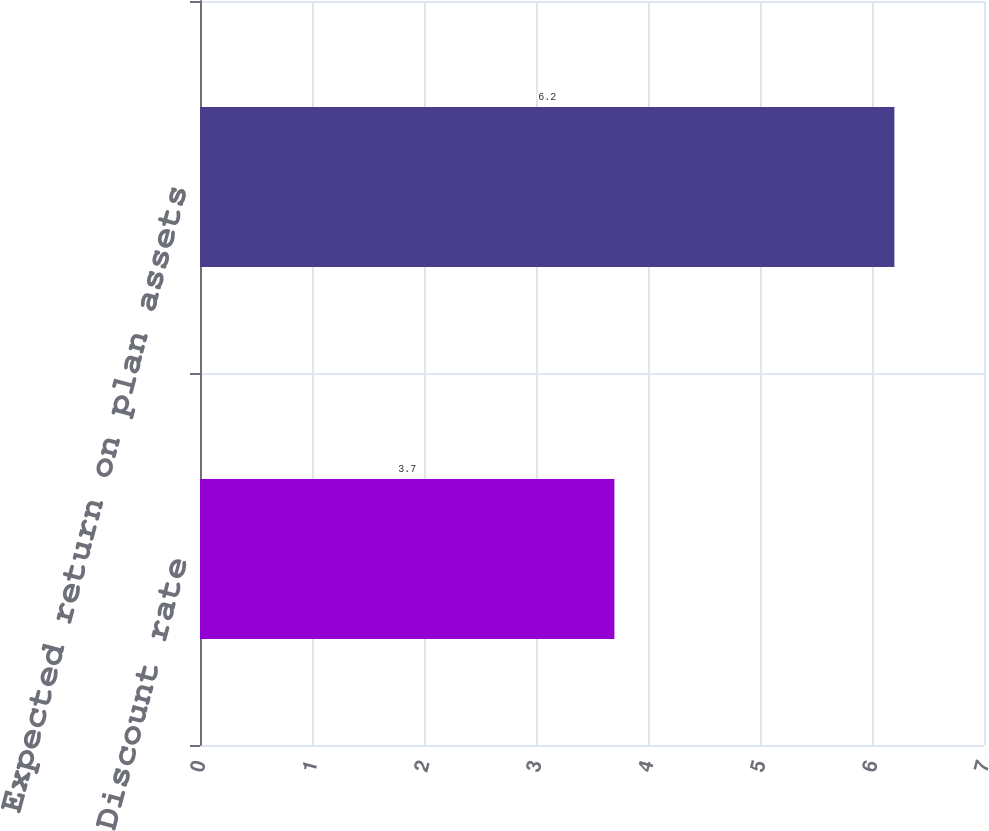Convert chart to OTSL. <chart><loc_0><loc_0><loc_500><loc_500><bar_chart><fcel>Discount rate<fcel>Expected return on plan assets<nl><fcel>3.7<fcel>6.2<nl></chart> 